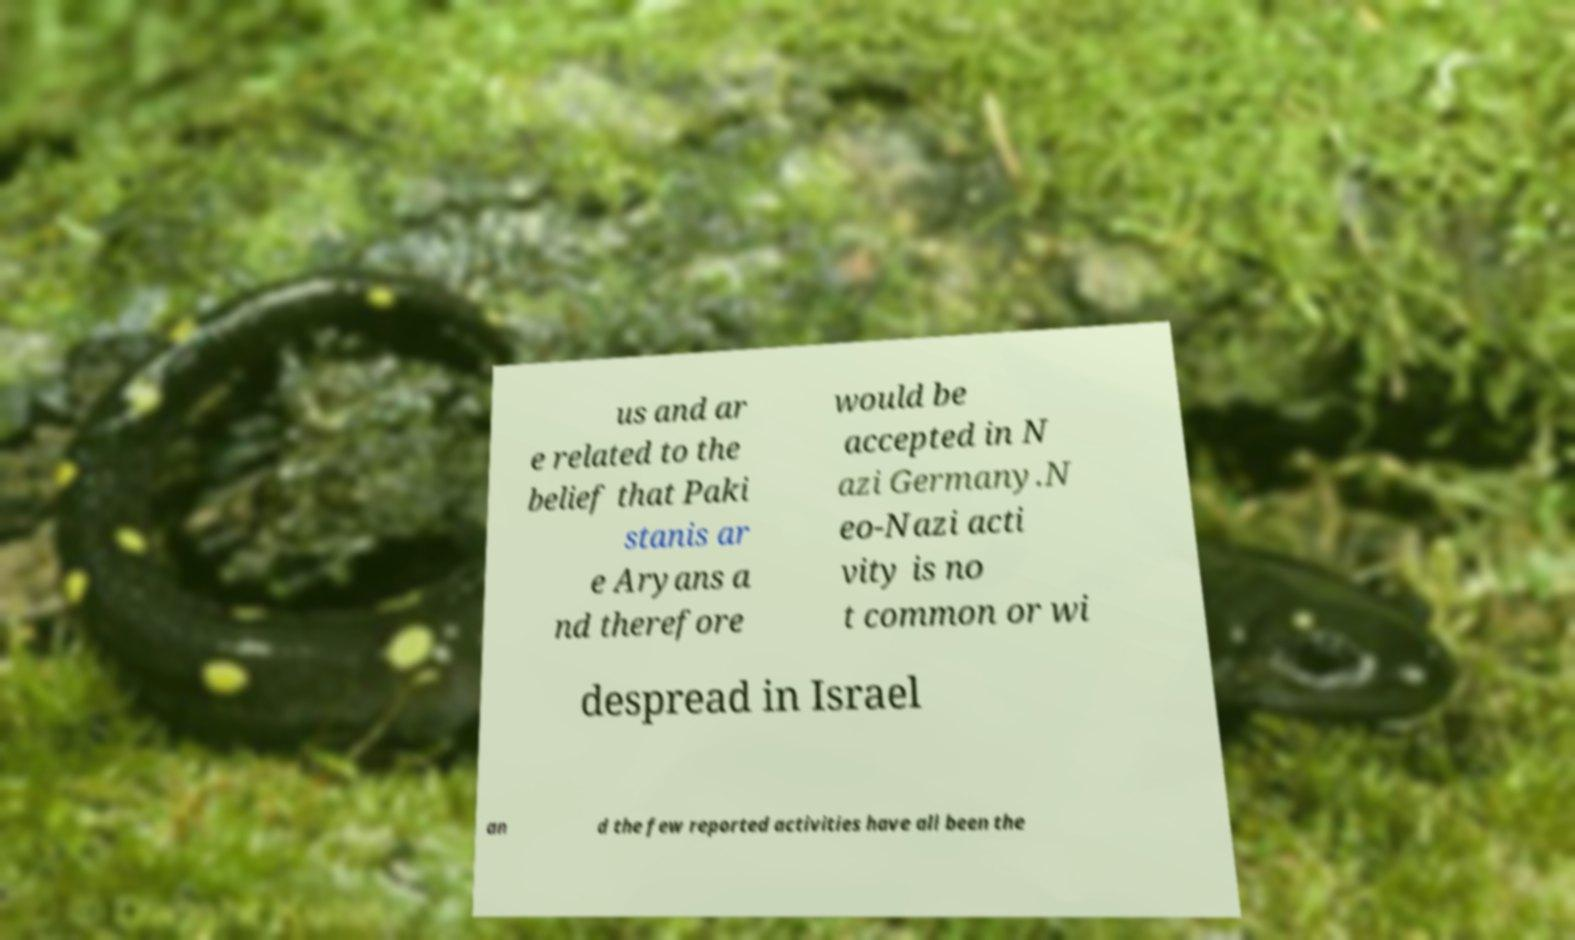Can you accurately transcribe the text from the provided image for me? us and ar e related to the belief that Paki stanis ar e Aryans a nd therefore would be accepted in N azi Germany.N eo-Nazi acti vity is no t common or wi despread in Israel an d the few reported activities have all been the 